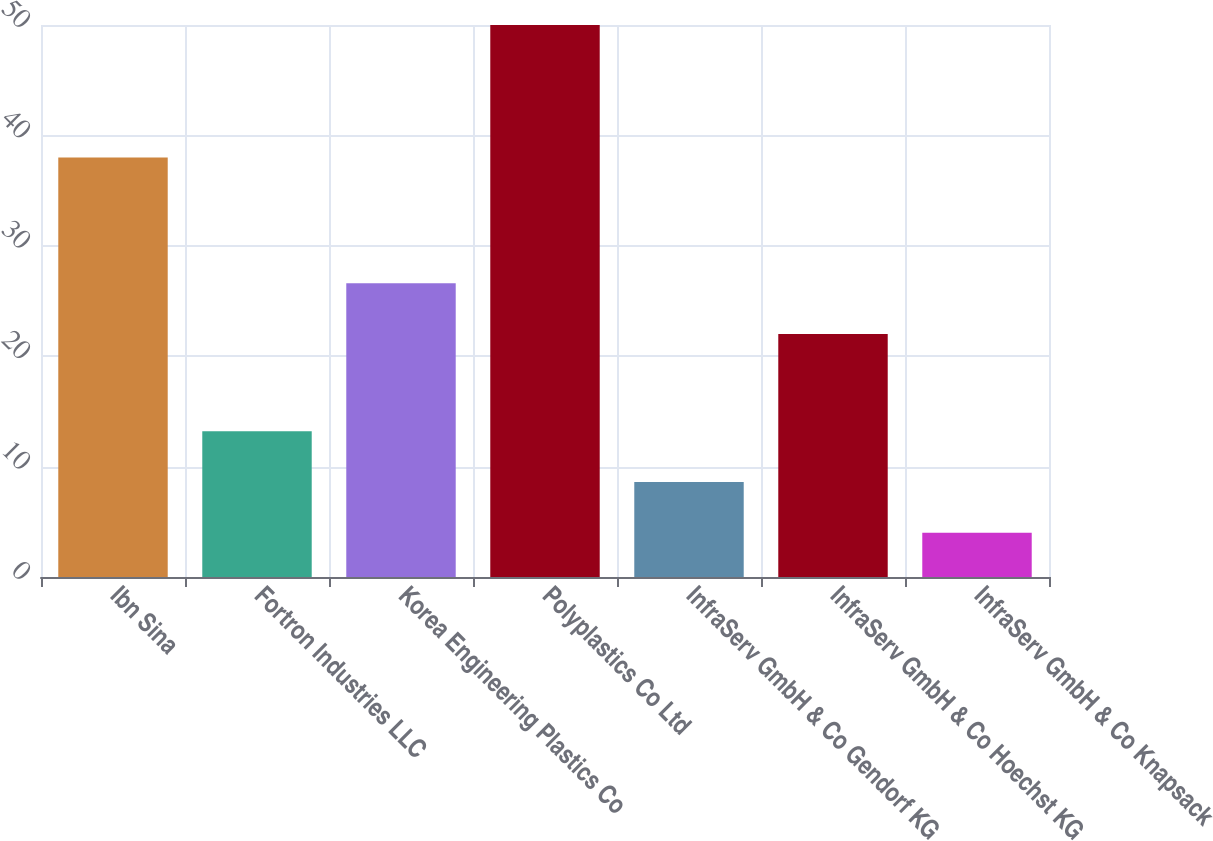<chart> <loc_0><loc_0><loc_500><loc_500><bar_chart><fcel>Ibn Sina<fcel>Fortron Industries LLC<fcel>Korea Engineering Plastics Co<fcel>Polyplastics Co Ltd<fcel>InfraServ GmbH & Co Gendorf KG<fcel>InfraServ GmbH & Co Hoechst KG<fcel>InfraServ GmbH & Co Knapsack<nl><fcel>38<fcel>13.2<fcel>26.6<fcel>50<fcel>8.6<fcel>22<fcel>4<nl></chart> 